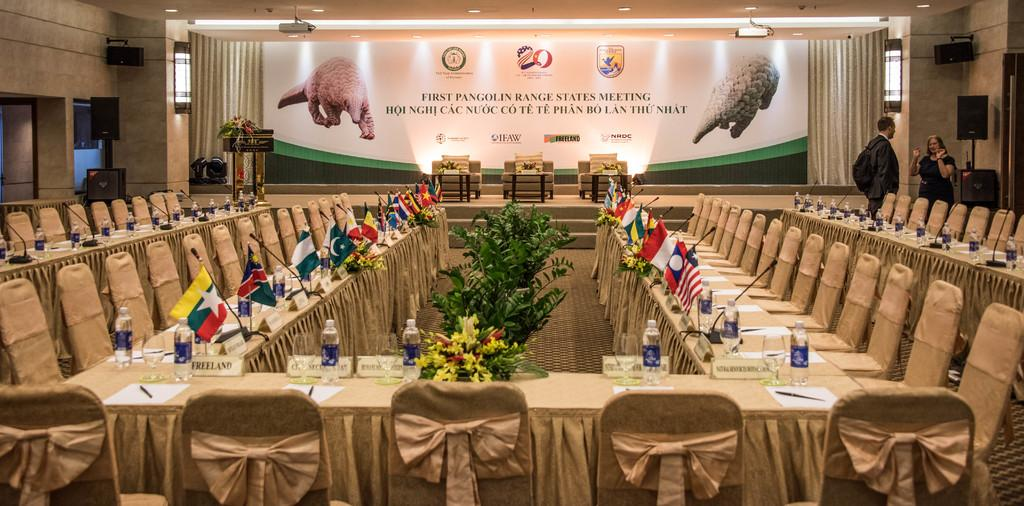What type of furniture is present in the image? There are chairs in the image. What objects are used for amplifying sound in the image? There are microphones in the image. What national symbols can be seen in the image? There are flags in the image. What beverages are on the tables in the image? There are bottles on tables in the image. What are the people in the image doing? There are people standing in the image. What is displayed on the stage in the image? There is a poster on the stage in the image. What type of riddle is being solved on the coast in the image? There is no riddle or coast present in the image. What type of meal is being served on the tables in the image? The tables in the image have bottles, not meals. 